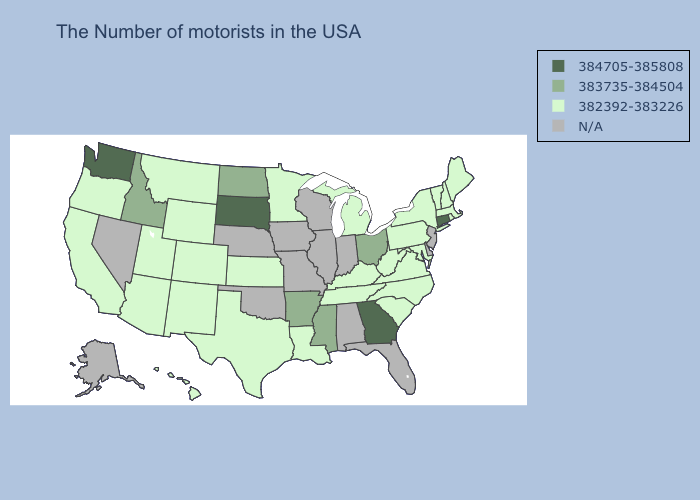Name the states that have a value in the range N/A?
Give a very brief answer. New Jersey, Delaware, Florida, Indiana, Alabama, Wisconsin, Illinois, Missouri, Iowa, Nebraska, Oklahoma, Nevada, Alaska. Which states have the lowest value in the USA?
Quick response, please. Maine, Massachusetts, Rhode Island, New Hampshire, Vermont, New York, Maryland, Pennsylvania, Virginia, North Carolina, South Carolina, West Virginia, Michigan, Kentucky, Tennessee, Louisiana, Minnesota, Kansas, Texas, Wyoming, Colorado, New Mexico, Utah, Montana, Arizona, California, Oregon, Hawaii. Among the states that border Washington , does Oregon have the highest value?
Concise answer only. No. Name the states that have a value in the range 384705-385808?
Answer briefly. Connecticut, Georgia, South Dakota, Washington. Which states have the lowest value in the Northeast?
Write a very short answer. Maine, Massachusetts, Rhode Island, New Hampshire, Vermont, New York, Pennsylvania. What is the highest value in states that border Oklahoma?
Concise answer only. 383735-384504. Which states hav the highest value in the Northeast?
Short answer required. Connecticut. What is the value of Colorado?
Write a very short answer. 382392-383226. Name the states that have a value in the range 383735-384504?
Give a very brief answer. Ohio, Mississippi, Arkansas, North Dakota, Idaho. What is the highest value in states that border Iowa?
Concise answer only. 384705-385808. Is the legend a continuous bar?
Short answer required. No. What is the value of Michigan?
Keep it brief. 382392-383226. What is the value of Illinois?
Short answer required. N/A. Among the states that border Wyoming , which have the lowest value?
Be succinct. Colorado, Utah, Montana. 